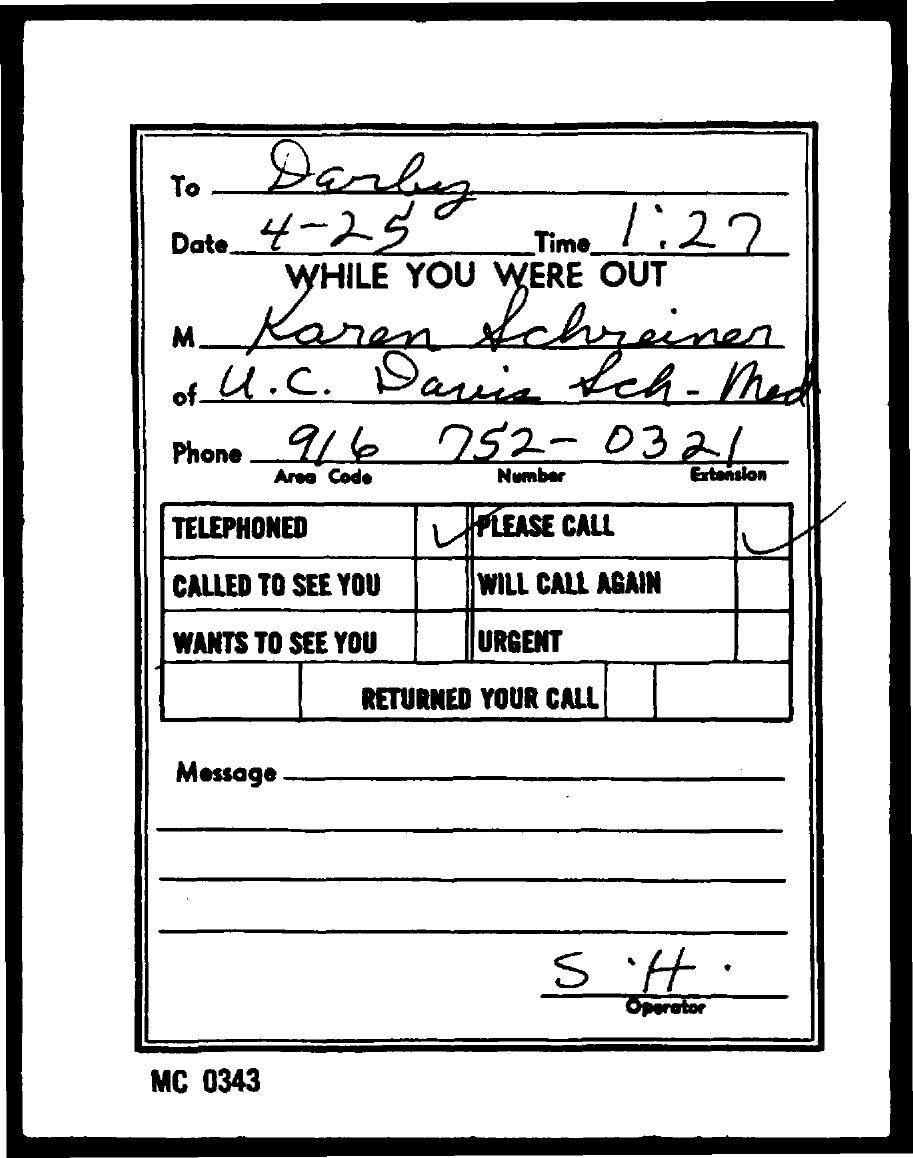What is the date given?
Offer a terse response. 4-25. What is the time given?
Ensure brevity in your answer.  1:27. What is the code mentioned at the bottom of the page?
Make the answer very short. MC 0343. 